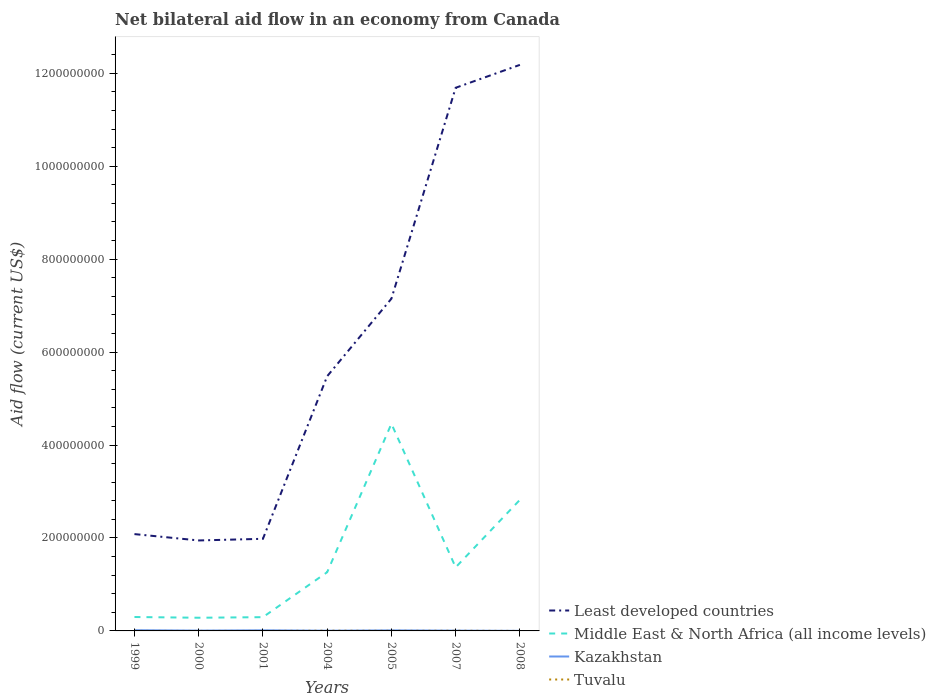How many different coloured lines are there?
Your response must be concise. 4. Across all years, what is the maximum net bilateral aid flow in Middle East & North Africa (all income levels)?
Your response must be concise. 2.84e+07. What is the total net bilateral aid flow in Middle East & North Africa (all income levels) in the graph?
Your answer should be compact. -1.07e+08. What is the difference between the highest and the second highest net bilateral aid flow in Kazakhstan?
Your answer should be compact. 1.35e+06. How many years are there in the graph?
Your response must be concise. 7. Does the graph contain grids?
Provide a succinct answer. No. How many legend labels are there?
Your answer should be compact. 4. How are the legend labels stacked?
Offer a very short reply. Vertical. What is the title of the graph?
Keep it short and to the point. Net bilateral aid flow in an economy from Canada. What is the label or title of the X-axis?
Offer a very short reply. Years. What is the Aid flow (current US$) in Least developed countries in 1999?
Your response must be concise. 2.08e+08. What is the Aid flow (current US$) of Middle East & North Africa (all income levels) in 1999?
Provide a short and direct response. 2.99e+07. What is the Aid flow (current US$) in Kazakhstan in 1999?
Your answer should be very brief. 1.53e+06. What is the Aid flow (current US$) in Least developed countries in 2000?
Your answer should be very brief. 1.95e+08. What is the Aid flow (current US$) of Middle East & North Africa (all income levels) in 2000?
Offer a very short reply. 2.84e+07. What is the Aid flow (current US$) in Kazakhstan in 2000?
Your answer should be compact. 7.10e+05. What is the Aid flow (current US$) in Tuvalu in 2000?
Your answer should be compact. 2.00e+04. What is the Aid flow (current US$) of Least developed countries in 2001?
Keep it short and to the point. 1.98e+08. What is the Aid flow (current US$) of Middle East & North Africa (all income levels) in 2001?
Provide a short and direct response. 2.96e+07. What is the Aid flow (current US$) in Kazakhstan in 2001?
Give a very brief answer. 1.31e+06. What is the Aid flow (current US$) of Least developed countries in 2004?
Your answer should be very brief. 5.48e+08. What is the Aid flow (current US$) in Middle East & North Africa (all income levels) in 2004?
Give a very brief answer. 1.26e+08. What is the Aid flow (current US$) in Kazakhstan in 2004?
Keep it short and to the point. 5.10e+05. What is the Aid flow (current US$) of Tuvalu in 2004?
Offer a terse response. 4.60e+05. What is the Aid flow (current US$) of Least developed countries in 2005?
Your response must be concise. 7.15e+08. What is the Aid flow (current US$) in Middle East & North Africa (all income levels) in 2005?
Keep it short and to the point. 4.46e+08. What is the Aid flow (current US$) in Kazakhstan in 2005?
Offer a very short reply. 1.18e+06. What is the Aid flow (current US$) in Least developed countries in 2007?
Offer a terse response. 1.17e+09. What is the Aid flow (current US$) in Middle East & North Africa (all income levels) in 2007?
Your answer should be very brief. 1.37e+08. What is the Aid flow (current US$) of Kazakhstan in 2007?
Ensure brevity in your answer.  6.30e+05. What is the Aid flow (current US$) in Tuvalu in 2007?
Your answer should be compact. 3.40e+05. What is the Aid flow (current US$) in Least developed countries in 2008?
Keep it short and to the point. 1.22e+09. What is the Aid flow (current US$) of Middle East & North Africa (all income levels) in 2008?
Offer a very short reply. 2.82e+08. What is the Aid flow (current US$) in Kazakhstan in 2008?
Offer a terse response. 1.80e+05. Across all years, what is the maximum Aid flow (current US$) of Least developed countries?
Make the answer very short. 1.22e+09. Across all years, what is the maximum Aid flow (current US$) in Middle East & North Africa (all income levels)?
Offer a terse response. 4.46e+08. Across all years, what is the maximum Aid flow (current US$) in Kazakhstan?
Offer a terse response. 1.53e+06. Across all years, what is the minimum Aid flow (current US$) in Least developed countries?
Offer a terse response. 1.95e+08. Across all years, what is the minimum Aid flow (current US$) of Middle East & North Africa (all income levels)?
Keep it short and to the point. 2.84e+07. Across all years, what is the minimum Aid flow (current US$) of Kazakhstan?
Provide a succinct answer. 1.80e+05. What is the total Aid flow (current US$) of Least developed countries in the graph?
Your answer should be compact. 4.25e+09. What is the total Aid flow (current US$) of Middle East & North Africa (all income levels) in the graph?
Your response must be concise. 1.08e+09. What is the total Aid flow (current US$) of Kazakhstan in the graph?
Your response must be concise. 6.05e+06. What is the total Aid flow (current US$) of Tuvalu in the graph?
Provide a succinct answer. 1.07e+06. What is the difference between the Aid flow (current US$) in Least developed countries in 1999 and that in 2000?
Your answer should be compact. 1.37e+07. What is the difference between the Aid flow (current US$) of Middle East & North Africa (all income levels) in 1999 and that in 2000?
Make the answer very short. 1.58e+06. What is the difference between the Aid flow (current US$) in Kazakhstan in 1999 and that in 2000?
Provide a short and direct response. 8.20e+05. What is the difference between the Aid flow (current US$) of Tuvalu in 1999 and that in 2000?
Keep it short and to the point. 0. What is the difference between the Aid flow (current US$) of Least developed countries in 1999 and that in 2001?
Your response must be concise. 1.02e+07. What is the difference between the Aid flow (current US$) in Tuvalu in 1999 and that in 2001?
Provide a short and direct response. 10000. What is the difference between the Aid flow (current US$) of Least developed countries in 1999 and that in 2004?
Keep it short and to the point. -3.40e+08. What is the difference between the Aid flow (current US$) of Middle East & North Africa (all income levels) in 1999 and that in 2004?
Make the answer very short. -9.64e+07. What is the difference between the Aid flow (current US$) in Kazakhstan in 1999 and that in 2004?
Your response must be concise. 1.02e+06. What is the difference between the Aid flow (current US$) of Tuvalu in 1999 and that in 2004?
Offer a terse response. -4.40e+05. What is the difference between the Aid flow (current US$) of Least developed countries in 1999 and that in 2005?
Provide a short and direct response. -5.07e+08. What is the difference between the Aid flow (current US$) of Middle East & North Africa (all income levels) in 1999 and that in 2005?
Your answer should be very brief. -4.16e+08. What is the difference between the Aid flow (current US$) in Tuvalu in 1999 and that in 2005?
Offer a terse response. -1.80e+05. What is the difference between the Aid flow (current US$) in Least developed countries in 1999 and that in 2007?
Give a very brief answer. -9.60e+08. What is the difference between the Aid flow (current US$) of Middle East & North Africa (all income levels) in 1999 and that in 2007?
Ensure brevity in your answer.  -1.07e+08. What is the difference between the Aid flow (current US$) of Tuvalu in 1999 and that in 2007?
Offer a terse response. -3.20e+05. What is the difference between the Aid flow (current US$) in Least developed countries in 1999 and that in 2008?
Keep it short and to the point. -1.01e+09. What is the difference between the Aid flow (current US$) of Middle East & North Africa (all income levels) in 1999 and that in 2008?
Make the answer very short. -2.52e+08. What is the difference between the Aid flow (current US$) of Kazakhstan in 1999 and that in 2008?
Keep it short and to the point. 1.35e+06. What is the difference between the Aid flow (current US$) in Least developed countries in 2000 and that in 2001?
Ensure brevity in your answer.  -3.52e+06. What is the difference between the Aid flow (current US$) of Middle East & North Africa (all income levels) in 2000 and that in 2001?
Provide a short and direct response. -1.25e+06. What is the difference between the Aid flow (current US$) in Kazakhstan in 2000 and that in 2001?
Your response must be concise. -6.00e+05. What is the difference between the Aid flow (current US$) in Tuvalu in 2000 and that in 2001?
Provide a succinct answer. 10000. What is the difference between the Aid flow (current US$) of Least developed countries in 2000 and that in 2004?
Your answer should be very brief. -3.53e+08. What is the difference between the Aid flow (current US$) of Middle East & North Africa (all income levels) in 2000 and that in 2004?
Provide a short and direct response. -9.80e+07. What is the difference between the Aid flow (current US$) in Kazakhstan in 2000 and that in 2004?
Keep it short and to the point. 2.00e+05. What is the difference between the Aid flow (current US$) in Tuvalu in 2000 and that in 2004?
Your response must be concise. -4.40e+05. What is the difference between the Aid flow (current US$) in Least developed countries in 2000 and that in 2005?
Give a very brief answer. -5.20e+08. What is the difference between the Aid flow (current US$) of Middle East & North Africa (all income levels) in 2000 and that in 2005?
Provide a short and direct response. -4.17e+08. What is the difference between the Aid flow (current US$) in Kazakhstan in 2000 and that in 2005?
Make the answer very short. -4.70e+05. What is the difference between the Aid flow (current US$) in Least developed countries in 2000 and that in 2007?
Ensure brevity in your answer.  -9.74e+08. What is the difference between the Aid flow (current US$) in Middle East & North Africa (all income levels) in 2000 and that in 2007?
Give a very brief answer. -1.08e+08. What is the difference between the Aid flow (current US$) in Kazakhstan in 2000 and that in 2007?
Your answer should be very brief. 8.00e+04. What is the difference between the Aid flow (current US$) of Tuvalu in 2000 and that in 2007?
Your answer should be very brief. -3.20e+05. What is the difference between the Aid flow (current US$) in Least developed countries in 2000 and that in 2008?
Offer a terse response. -1.02e+09. What is the difference between the Aid flow (current US$) in Middle East & North Africa (all income levels) in 2000 and that in 2008?
Provide a short and direct response. -2.54e+08. What is the difference between the Aid flow (current US$) of Kazakhstan in 2000 and that in 2008?
Give a very brief answer. 5.30e+05. What is the difference between the Aid flow (current US$) in Least developed countries in 2001 and that in 2004?
Make the answer very short. -3.50e+08. What is the difference between the Aid flow (current US$) of Middle East & North Africa (all income levels) in 2001 and that in 2004?
Your response must be concise. -9.68e+07. What is the difference between the Aid flow (current US$) in Kazakhstan in 2001 and that in 2004?
Ensure brevity in your answer.  8.00e+05. What is the difference between the Aid flow (current US$) of Tuvalu in 2001 and that in 2004?
Your answer should be very brief. -4.50e+05. What is the difference between the Aid flow (current US$) of Least developed countries in 2001 and that in 2005?
Ensure brevity in your answer.  -5.17e+08. What is the difference between the Aid flow (current US$) of Middle East & North Africa (all income levels) in 2001 and that in 2005?
Give a very brief answer. -4.16e+08. What is the difference between the Aid flow (current US$) in Tuvalu in 2001 and that in 2005?
Provide a succinct answer. -1.90e+05. What is the difference between the Aid flow (current US$) of Least developed countries in 2001 and that in 2007?
Give a very brief answer. -9.71e+08. What is the difference between the Aid flow (current US$) of Middle East & North Africa (all income levels) in 2001 and that in 2007?
Offer a very short reply. -1.07e+08. What is the difference between the Aid flow (current US$) in Kazakhstan in 2001 and that in 2007?
Keep it short and to the point. 6.80e+05. What is the difference between the Aid flow (current US$) of Tuvalu in 2001 and that in 2007?
Your answer should be compact. -3.30e+05. What is the difference between the Aid flow (current US$) in Least developed countries in 2001 and that in 2008?
Your answer should be compact. -1.02e+09. What is the difference between the Aid flow (current US$) in Middle East & North Africa (all income levels) in 2001 and that in 2008?
Keep it short and to the point. -2.52e+08. What is the difference between the Aid flow (current US$) in Kazakhstan in 2001 and that in 2008?
Your response must be concise. 1.13e+06. What is the difference between the Aid flow (current US$) of Tuvalu in 2001 and that in 2008?
Make the answer very short. -10000. What is the difference between the Aid flow (current US$) in Least developed countries in 2004 and that in 2005?
Provide a short and direct response. -1.67e+08. What is the difference between the Aid flow (current US$) in Middle East & North Africa (all income levels) in 2004 and that in 2005?
Offer a terse response. -3.19e+08. What is the difference between the Aid flow (current US$) in Kazakhstan in 2004 and that in 2005?
Your answer should be compact. -6.70e+05. What is the difference between the Aid flow (current US$) in Least developed countries in 2004 and that in 2007?
Keep it short and to the point. -6.21e+08. What is the difference between the Aid flow (current US$) in Middle East & North Africa (all income levels) in 2004 and that in 2007?
Your answer should be compact. -1.05e+07. What is the difference between the Aid flow (current US$) of Kazakhstan in 2004 and that in 2007?
Ensure brevity in your answer.  -1.20e+05. What is the difference between the Aid flow (current US$) in Tuvalu in 2004 and that in 2007?
Your answer should be compact. 1.20e+05. What is the difference between the Aid flow (current US$) of Least developed countries in 2004 and that in 2008?
Your response must be concise. -6.70e+08. What is the difference between the Aid flow (current US$) in Middle East & North Africa (all income levels) in 2004 and that in 2008?
Your response must be concise. -1.56e+08. What is the difference between the Aid flow (current US$) of Kazakhstan in 2004 and that in 2008?
Make the answer very short. 3.30e+05. What is the difference between the Aid flow (current US$) of Least developed countries in 2005 and that in 2007?
Your response must be concise. -4.54e+08. What is the difference between the Aid flow (current US$) of Middle East & North Africa (all income levels) in 2005 and that in 2007?
Ensure brevity in your answer.  3.09e+08. What is the difference between the Aid flow (current US$) of Kazakhstan in 2005 and that in 2007?
Your answer should be very brief. 5.50e+05. What is the difference between the Aid flow (current US$) in Least developed countries in 2005 and that in 2008?
Provide a short and direct response. -5.03e+08. What is the difference between the Aid flow (current US$) in Middle East & North Africa (all income levels) in 2005 and that in 2008?
Keep it short and to the point. 1.64e+08. What is the difference between the Aid flow (current US$) of Kazakhstan in 2005 and that in 2008?
Offer a very short reply. 1.00e+06. What is the difference between the Aid flow (current US$) in Least developed countries in 2007 and that in 2008?
Your answer should be compact. -4.93e+07. What is the difference between the Aid flow (current US$) in Middle East & North Africa (all income levels) in 2007 and that in 2008?
Offer a terse response. -1.45e+08. What is the difference between the Aid flow (current US$) of Least developed countries in 1999 and the Aid flow (current US$) of Middle East & North Africa (all income levels) in 2000?
Offer a very short reply. 1.80e+08. What is the difference between the Aid flow (current US$) in Least developed countries in 1999 and the Aid flow (current US$) in Kazakhstan in 2000?
Give a very brief answer. 2.08e+08. What is the difference between the Aid flow (current US$) in Least developed countries in 1999 and the Aid flow (current US$) in Tuvalu in 2000?
Make the answer very short. 2.08e+08. What is the difference between the Aid flow (current US$) of Middle East & North Africa (all income levels) in 1999 and the Aid flow (current US$) of Kazakhstan in 2000?
Give a very brief answer. 2.92e+07. What is the difference between the Aid flow (current US$) in Middle East & North Africa (all income levels) in 1999 and the Aid flow (current US$) in Tuvalu in 2000?
Keep it short and to the point. 2.99e+07. What is the difference between the Aid flow (current US$) in Kazakhstan in 1999 and the Aid flow (current US$) in Tuvalu in 2000?
Your answer should be very brief. 1.51e+06. What is the difference between the Aid flow (current US$) of Least developed countries in 1999 and the Aid flow (current US$) of Middle East & North Africa (all income levels) in 2001?
Ensure brevity in your answer.  1.79e+08. What is the difference between the Aid flow (current US$) of Least developed countries in 1999 and the Aid flow (current US$) of Kazakhstan in 2001?
Offer a very short reply. 2.07e+08. What is the difference between the Aid flow (current US$) of Least developed countries in 1999 and the Aid flow (current US$) of Tuvalu in 2001?
Make the answer very short. 2.08e+08. What is the difference between the Aid flow (current US$) in Middle East & North Africa (all income levels) in 1999 and the Aid flow (current US$) in Kazakhstan in 2001?
Offer a terse response. 2.86e+07. What is the difference between the Aid flow (current US$) of Middle East & North Africa (all income levels) in 1999 and the Aid flow (current US$) of Tuvalu in 2001?
Your response must be concise. 2.99e+07. What is the difference between the Aid flow (current US$) of Kazakhstan in 1999 and the Aid flow (current US$) of Tuvalu in 2001?
Give a very brief answer. 1.52e+06. What is the difference between the Aid flow (current US$) of Least developed countries in 1999 and the Aid flow (current US$) of Middle East & North Africa (all income levels) in 2004?
Provide a short and direct response. 8.20e+07. What is the difference between the Aid flow (current US$) in Least developed countries in 1999 and the Aid flow (current US$) in Kazakhstan in 2004?
Your answer should be very brief. 2.08e+08. What is the difference between the Aid flow (current US$) in Least developed countries in 1999 and the Aid flow (current US$) in Tuvalu in 2004?
Your answer should be compact. 2.08e+08. What is the difference between the Aid flow (current US$) of Middle East & North Africa (all income levels) in 1999 and the Aid flow (current US$) of Kazakhstan in 2004?
Ensure brevity in your answer.  2.94e+07. What is the difference between the Aid flow (current US$) of Middle East & North Africa (all income levels) in 1999 and the Aid flow (current US$) of Tuvalu in 2004?
Offer a terse response. 2.95e+07. What is the difference between the Aid flow (current US$) of Kazakhstan in 1999 and the Aid flow (current US$) of Tuvalu in 2004?
Provide a short and direct response. 1.07e+06. What is the difference between the Aid flow (current US$) of Least developed countries in 1999 and the Aid flow (current US$) of Middle East & North Africa (all income levels) in 2005?
Make the answer very short. -2.37e+08. What is the difference between the Aid flow (current US$) in Least developed countries in 1999 and the Aid flow (current US$) in Kazakhstan in 2005?
Provide a short and direct response. 2.07e+08. What is the difference between the Aid flow (current US$) in Least developed countries in 1999 and the Aid flow (current US$) in Tuvalu in 2005?
Your response must be concise. 2.08e+08. What is the difference between the Aid flow (current US$) of Middle East & North Africa (all income levels) in 1999 and the Aid flow (current US$) of Kazakhstan in 2005?
Your answer should be compact. 2.88e+07. What is the difference between the Aid flow (current US$) in Middle East & North Africa (all income levels) in 1999 and the Aid flow (current US$) in Tuvalu in 2005?
Provide a short and direct response. 2.97e+07. What is the difference between the Aid flow (current US$) in Kazakhstan in 1999 and the Aid flow (current US$) in Tuvalu in 2005?
Provide a succinct answer. 1.33e+06. What is the difference between the Aid flow (current US$) in Least developed countries in 1999 and the Aid flow (current US$) in Middle East & North Africa (all income levels) in 2007?
Ensure brevity in your answer.  7.15e+07. What is the difference between the Aid flow (current US$) of Least developed countries in 1999 and the Aid flow (current US$) of Kazakhstan in 2007?
Ensure brevity in your answer.  2.08e+08. What is the difference between the Aid flow (current US$) in Least developed countries in 1999 and the Aid flow (current US$) in Tuvalu in 2007?
Give a very brief answer. 2.08e+08. What is the difference between the Aid flow (current US$) of Middle East & North Africa (all income levels) in 1999 and the Aid flow (current US$) of Kazakhstan in 2007?
Your response must be concise. 2.93e+07. What is the difference between the Aid flow (current US$) in Middle East & North Africa (all income levels) in 1999 and the Aid flow (current US$) in Tuvalu in 2007?
Provide a short and direct response. 2.96e+07. What is the difference between the Aid flow (current US$) in Kazakhstan in 1999 and the Aid flow (current US$) in Tuvalu in 2007?
Make the answer very short. 1.19e+06. What is the difference between the Aid flow (current US$) in Least developed countries in 1999 and the Aid flow (current US$) in Middle East & North Africa (all income levels) in 2008?
Give a very brief answer. -7.37e+07. What is the difference between the Aid flow (current US$) of Least developed countries in 1999 and the Aid flow (current US$) of Kazakhstan in 2008?
Provide a succinct answer. 2.08e+08. What is the difference between the Aid flow (current US$) of Least developed countries in 1999 and the Aid flow (current US$) of Tuvalu in 2008?
Make the answer very short. 2.08e+08. What is the difference between the Aid flow (current US$) of Middle East & North Africa (all income levels) in 1999 and the Aid flow (current US$) of Kazakhstan in 2008?
Make the answer very short. 2.98e+07. What is the difference between the Aid flow (current US$) in Middle East & North Africa (all income levels) in 1999 and the Aid flow (current US$) in Tuvalu in 2008?
Provide a succinct answer. 2.99e+07. What is the difference between the Aid flow (current US$) of Kazakhstan in 1999 and the Aid flow (current US$) of Tuvalu in 2008?
Give a very brief answer. 1.51e+06. What is the difference between the Aid flow (current US$) of Least developed countries in 2000 and the Aid flow (current US$) of Middle East & North Africa (all income levels) in 2001?
Provide a succinct answer. 1.65e+08. What is the difference between the Aid flow (current US$) of Least developed countries in 2000 and the Aid flow (current US$) of Kazakhstan in 2001?
Offer a terse response. 1.93e+08. What is the difference between the Aid flow (current US$) of Least developed countries in 2000 and the Aid flow (current US$) of Tuvalu in 2001?
Give a very brief answer. 1.95e+08. What is the difference between the Aid flow (current US$) in Middle East & North Africa (all income levels) in 2000 and the Aid flow (current US$) in Kazakhstan in 2001?
Your answer should be very brief. 2.70e+07. What is the difference between the Aid flow (current US$) in Middle East & North Africa (all income levels) in 2000 and the Aid flow (current US$) in Tuvalu in 2001?
Provide a short and direct response. 2.84e+07. What is the difference between the Aid flow (current US$) in Least developed countries in 2000 and the Aid flow (current US$) in Middle East & North Africa (all income levels) in 2004?
Keep it short and to the point. 6.83e+07. What is the difference between the Aid flow (current US$) of Least developed countries in 2000 and the Aid flow (current US$) of Kazakhstan in 2004?
Your answer should be compact. 1.94e+08. What is the difference between the Aid flow (current US$) of Least developed countries in 2000 and the Aid flow (current US$) of Tuvalu in 2004?
Your answer should be compact. 1.94e+08. What is the difference between the Aid flow (current US$) in Middle East & North Africa (all income levels) in 2000 and the Aid flow (current US$) in Kazakhstan in 2004?
Offer a very short reply. 2.78e+07. What is the difference between the Aid flow (current US$) in Middle East & North Africa (all income levels) in 2000 and the Aid flow (current US$) in Tuvalu in 2004?
Offer a terse response. 2.79e+07. What is the difference between the Aid flow (current US$) of Kazakhstan in 2000 and the Aid flow (current US$) of Tuvalu in 2004?
Ensure brevity in your answer.  2.50e+05. What is the difference between the Aid flow (current US$) in Least developed countries in 2000 and the Aid flow (current US$) in Middle East & North Africa (all income levels) in 2005?
Ensure brevity in your answer.  -2.51e+08. What is the difference between the Aid flow (current US$) in Least developed countries in 2000 and the Aid flow (current US$) in Kazakhstan in 2005?
Keep it short and to the point. 1.94e+08. What is the difference between the Aid flow (current US$) of Least developed countries in 2000 and the Aid flow (current US$) of Tuvalu in 2005?
Provide a short and direct response. 1.94e+08. What is the difference between the Aid flow (current US$) of Middle East & North Africa (all income levels) in 2000 and the Aid flow (current US$) of Kazakhstan in 2005?
Your answer should be very brief. 2.72e+07. What is the difference between the Aid flow (current US$) in Middle East & North Africa (all income levels) in 2000 and the Aid flow (current US$) in Tuvalu in 2005?
Give a very brief answer. 2.82e+07. What is the difference between the Aid flow (current US$) of Kazakhstan in 2000 and the Aid flow (current US$) of Tuvalu in 2005?
Give a very brief answer. 5.10e+05. What is the difference between the Aid flow (current US$) in Least developed countries in 2000 and the Aid flow (current US$) in Middle East & North Africa (all income levels) in 2007?
Make the answer very short. 5.78e+07. What is the difference between the Aid flow (current US$) in Least developed countries in 2000 and the Aid flow (current US$) in Kazakhstan in 2007?
Your answer should be very brief. 1.94e+08. What is the difference between the Aid flow (current US$) of Least developed countries in 2000 and the Aid flow (current US$) of Tuvalu in 2007?
Your answer should be compact. 1.94e+08. What is the difference between the Aid flow (current US$) of Middle East & North Africa (all income levels) in 2000 and the Aid flow (current US$) of Kazakhstan in 2007?
Offer a very short reply. 2.77e+07. What is the difference between the Aid flow (current US$) of Middle East & North Africa (all income levels) in 2000 and the Aid flow (current US$) of Tuvalu in 2007?
Offer a terse response. 2.80e+07. What is the difference between the Aid flow (current US$) in Least developed countries in 2000 and the Aid flow (current US$) in Middle East & North Africa (all income levels) in 2008?
Your answer should be compact. -8.74e+07. What is the difference between the Aid flow (current US$) of Least developed countries in 2000 and the Aid flow (current US$) of Kazakhstan in 2008?
Keep it short and to the point. 1.94e+08. What is the difference between the Aid flow (current US$) of Least developed countries in 2000 and the Aid flow (current US$) of Tuvalu in 2008?
Offer a very short reply. 1.95e+08. What is the difference between the Aid flow (current US$) of Middle East & North Africa (all income levels) in 2000 and the Aid flow (current US$) of Kazakhstan in 2008?
Provide a succinct answer. 2.82e+07. What is the difference between the Aid flow (current US$) of Middle East & North Africa (all income levels) in 2000 and the Aid flow (current US$) of Tuvalu in 2008?
Your response must be concise. 2.83e+07. What is the difference between the Aid flow (current US$) in Kazakhstan in 2000 and the Aid flow (current US$) in Tuvalu in 2008?
Give a very brief answer. 6.90e+05. What is the difference between the Aid flow (current US$) in Least developed countries in 2001 and the Aid flow (current US$) in Middle East & North Africa (all income levels) in 2004?
Provide a short and direct response. 7.18e+07. What is the difference between the Aid flow (current US$) of Least developed countries in 2001 and the Aid flow (current US$) of Kazakhstan in 2004?
Ensure brevity in your answer.  1.98e+08. What is the difference between the Aid flow (current US$) of Least developed countries in 2001 and the Aid flow (current US$) of Tuvalu in 2004?
Provide a short and direct response. 1.98e+08. What is the difference between the Aid flow (current US$) in Middle East & North Africa (all income levels) in 2001 and the Aid flow (current US$) in Kazakhstan in 2004?
Your response must be concise. 2.91e+07. What is the difference between the Aid flow (current US$) in Middle East & North Africa (all income levels) in 2001 and the Aid flow (current US$) in Tuvalu in 2004?
Give a very brief answer. 2.92e+07. What is the difference between the Aid flow (current US$) in Kazakhstan in 2001 and the Aid flow (current US$) in Tuvalu in 2004?
Keep it short and to the point. 8.50e+05. What is the difference between the Aid flow (current US$) of Least developed countries in 2001 and the Aid flow (current US$) of Middle East & North Africa (all income levels) in 2005?
Make the answer very short. -2.48e+08. What is the difference between the Aid flow (current US$) of Least developed countries in 2001 and the Aid flow (current US$) of Kazakhstan in 2005?
Make the answer very short. 1.97e+08. What is the difference between the Aid flow (current US$) of Least developed countries in 2001 and the Aid flow (current US$) of Tuvalu in 2005?
Your answer should be compact. 1.98e+08. What is the difference between the Aid flow (current US$) of Middle East & North Africa (all income levels) in 2001 and the Aid flow (current US$) of Kazakhstan in 2005?
Provide a succinct answer. 2.84e+07. What is the difference between the Aid flow (current US$) of Middle East & North Africa (all income levels) in 2001 and the Aid flow (current US$) of Tuvalu in 2005?
Give a very brief answer. 2.94e+07. What is the difference between the Aid flow (current US$) of Kazakhstan in 2001 and the Aid flow (current US$) of Tuvalu in 2005?
Provide a succinct answer. 1.11e+06. What is the difference between the Aid flow (current US$) of Least developed countries in 2001 and the Aid flow (current US$) of Middle East & North Africa (all income levels) in 2007?
Ensure brevity in your answer.  6.14e+07. What is the difference between the Aid flow (current US$) of Least developed countries in 2001 and the Aid flow (current US$) of Kazakhstan in 2007?
Your response must be concise. 1.98e+08. What is the difference between the Aid flow (current US$) in Least developed countries in 2001 and the Aid flow (current US$) in Tuvalu in 2007?
Offer a terse response. 1.98e+08. What is the difference between the Aid flow (current US$) of Middle East & North Africa (all income levels) in 2001 and the Aid flow (current US$) of Kazakhstan in 2007?
Your answer should be very brief. 2.90e+07. What is the difference between the Aid flow (current US$) in Middle East & North Africa (all income levels) in 2001 and the Aid flow (current US$) in Tuvalu in 2007?
Your answer should be very brief. 2.93e+07. What is the difference between the Aid flow (current US$) of Kazakhstan in 2001 and the Aid flow (current US$) of Tuvalu in 2007?
Your answer should be compact. 9.70e+05. What is the difference between the Aid flow (current US$) in Least developed countries in 2001 and the Aid flow (current US$) in Middle East & North Africa (all income levels) in 2008?
Provide a short and direct response. -8.39e+07. What is the difference between the Aid flow (current US$) in Least developed countries in 2001 and the Aid flow (current US$) in Kazakhstan in 2008?
Provide a succinct answer. 1.98e+08. What is the difference between the Aid flow (current US$) of Least developed countries in 2001 and the Aid flow (current US$) of Tuvalu in 2008?
Give a very brief answer. 1.98e+08. What is the difference between the Aid flow (current US$) in Middle East & North Africa (all income levels) in 2001 and the Aid flow (current US$) in Kazakhstan in 2008?
Your response must be concise. 2.94e+07. What is the difference between the Aid flow (current US$) of Middle East & North Africa (all income levels) in 2001 and the Aid flow (current US$) of Tuvalu in 2008?
Give a very brief answer. 2.96e+07. What is the difference between the Aid flow (current US$) in Kazakhstan in 2001 and the Aid flow (current US$) in Tuvalu in 2008?
Make the answer very short. 1.29e+06. What is the difference between the Aid flow (current US$) in Least developed countries in 2004 and the Aid flow (current US$) in Middle East & North Africa (all income levels) in 2005?
Ensure brevity in your answer.  1.02e+08. What is the difference between the Aid flow (current US$) in Least developed countries in 2004 and the Aid flow (current US$) in Kazakhstan in 2005?
Make the answer very short. 5.47e+08. What is the difference between the Aid flow (current US$) in Least developed countries in 2004 and the Aid flow (current US$) in Tuvalu in 2005?
Give a very brief answer. 5.48e+08. What is the difference between the Aid flow (current US$) of Middle East & North Africa (all income levels) in 2004 and the Aid flow (current US$) of Kazakhstan in 2005?
Your answer should be very brief. 1.25e+08. What is the difference between the Aid flow (current US$) in Middle East & North Africa (all income levels) in 2004 and the Aid flow (current US$) in Tuvalu in 2005?
Give a very brief answer. 1.26e+08. What is the difference between the Aid flow (current US$) in Kazakhstan in 2004 and the Aid flow (current US$) in Tuvalu in 2005?
Offer a terse response. 3.10e+05. What is the difference between the Aid flow (current US$) in Least developed countries in 2004 and the Aid flow (current US$) in Middle East & North Africa (all income levels) in 2007?
Your answer should be very brief. 4.11e+08. What is the difference between the Aid flow (current US$) of Least developed countries in 2004 and the Aid flow (current US$) of Kazakhstan in 2007?
Ensure brevity in your answer.  5.47e+08. What is the difference between the Aid flow (current US$) in Least developed countries in 2004 and the Aid flow (current US$) in Tuvalu in 2007?
Ensure brevity in your answer.  5.48e+08. What is the difference between the Aid flow (current US$) in Middle East & North Africa (all income levels) in 2004 and the Aid flow (current US$) in Kazakhstan in 2007?
Your response must be concise. 1.26e+08. What is the difference between the Aid flow (current US$) in Middle East & North Africa (all income levels) in 2004 and the Aid flow (current US$) in Tuvalu in 2007?
Your answer should be very brief. 1.26e+08. What is the difference between the Aid flow (current US$) in Kazakhstan in 2004 and the Aid flow (current US$) in Tuvalu in 2007?
Keep it short and to the point. 1.70e+05. What is the difference between the Aid flow (current US$) in Least developed countries in 2004 and the Aid flow (current US$) in Middle East & North Africa (all income levels) in 2008?
Ensure brevity in your answer.  2.66e+08. What is the difference between the Aid flow (current US$) of Least developed countries in 2004 and the Aid flow (current US$) of Kazakhstan in 2008?
Give a very brief answer. 5.48e+08. What is the difference between the Aid flow (current US$) in Least developed countries in 2004 and the Aid flow (current US$) in Tuvalu in 2008?
Your answer should be very brief. 5.48e+08. What is the difference between the Aid flow (current US$) in Middle East & North Africa (all income levels) in 2004 and the Aid flow (current US$) in Kazakhstan in 2008?
Offer a terse response. 1.26e+08. What is the difference between the Aid flow (current US$) of Middle East & North Africa (all income levels) in 2004 and the Aid flow (current US$) of Tuvalu in 2008?
Offer a terse response. 1.26e+08. What is the difference between the Aid flow (current US$) in Least developed countries in 2005 and the Aid flow (current US$) in Middle East & North Africa (all income levels) in 2007?
Provide a succinct answer. 5.78e+08. What is the difference between the Aid flow (current US$) of Least developed countries in 2005 and the Aid flow (current US$) of Kazakhstan in 2007?
Make the answer very short. 7.14e+08. What is the difference between the Aid flow (current US$) of Least developed countries in 2005 and the Aid flow (current US$) of Tuvalu in 2007?
Your answer should be very brief. 7.15e+08. What is the difference between the Aid flow (current US$) of Middle East & North Africa (all income levels) in 2005 and the Aid flow (current US$) of Kazakhstan in 2007?
Ensure brevity in your answer.  4.45e+08. What is the difference between the Aid flow (current US$) in Middle East & North Africa (all income levels) in 2005 and the Aid flow (current US$) in Tuvalu in 2007?
Provide a short and direct response. 4.45e+08. What is the difference between the Aid flow (current US$) of Kazakhstan in 2005 and the Aid flow (current US$) of Tuvalu in 2007?
Your answer should be very brief. 8.40e+05. What is the difference between the Aid flow (current US$) in Least developed countries in 2005 and the Aid flow (current US$) in Middle East & North Africa (all income levels) in 2008?
Offer a terse response. 4.33e+08. What is the difference between the Aid flow (current US$) in Least developed countries in 2005 and the Aid flow (current US$) in Kazakhstan in 2008?
Ensure brevity in your answer.  7.15e+08. What is the difference between the Aid flow (current US$) of Least developed countries in 2005 and the Aid flow (current US$) of Tuvalu in 2008?
Your answer should be very brief. 7.15e+08. What is the difference between the Aid flow (current US$) in Middle East & North Africa (all income levels) in 2005 and the Aid flow (current US$) in Kazakhstan in 2008?
Provide a succinct answer. 4.46e+08. What is the difference between the Aid flow (current US$) in Middle East & North Africa (all income levels) in 2005 and the Aid flow (current US$) in Tuvalu in 2008?
Make the answer very short. 4.46e+08. What is the difference between the Aid flow (current US$) of Kazakhstan in 2005 and the Aid flow (current US$) of Tuvalu in 2008?
Offer a terse response. 1.16e+06. What is the difference between the Aid flow (current US$) of Least developed countries in 2007 and the Aid flow (current US$) of Middle East & North Africa (all income levels) in 2008?
Your answer should be compact. 8.87e+08. What is the difference between the Aid flow (current US$) of Least developed countries in 2007 and the Aid flow (current US$) of Kazakhstan in 2008?
Ensure brevity in your answer.  1.17e+09. What is the difference between the Aid flow (current US$) of Least developed countries in 2007 and the Aid flow (current US$) of Tuvalu in 2008?
Give a very brief answer. 1.17e+09. What is the difference between the Aid flow (current US$) in Middle East & North Africa (all income levels) in 2007 and the Aid flow (current US$) in Kazakhstan in 2008?
Offer a terse response. 1.37e+08. What is the difference between the Aid flow (current US$) in Middle East & North Africa (all income levels) in 2007 and the Aid flow (current US$) in Tuvalu in 2008?
Your answer should be compact. 1.37e+08. What is the difference between the Aid flow (current US$) of Kazakhstan in 2007 and the Aid flow (current US$) of Tuvalu in 2008?
Provide a succinct answer. 6.10e+05. What is the average Aid flow (current US$) of Least developed countries per year?
Your answer should be very brief. 6.07e+08. What is the average Aid flow (current US$) of Middle East & North Africa (all income levels) per year?
Your response must be concise. 1.54e+08. What is the average Aid flow (current US$) in Kazakhstan per year?
Your answer should be very brief. 8.64e+05. What is the average Aid flow (current US$) of Tuvalu per year?
Ensure brevity in your answer.  1.53e+05. In the year 1999, what is the difference between the Aid flow (current US$) of Least developed countries and Aid flow (current US$) of Middle East & North Africa (all income levels)?
Your answer should be compact. 1.78e+08. In the year 1999, what is the difference between the Aid flow (current US$) in Least developed countries and Aid flow (current US$) in Kazakhstan?
Keep it short and to the point. 2.07e+08. In the year 1999, what is the difference between the Aid flow (current US$) in Least developed countries and Aid flow (current US$) in Tuvalu?
Give a very brief answer. 2.08e+08. In the year 1999, what is the difference between the Aid flow (current US$) of Middle East & North Africa (all income levels) and Aid flow (current US$) of Kazakhstan?
Your answer should be compact. 2.84e+07. In the year 1999, what is the difference between the Aid flow (current US$) in Middle East & North Africa (all income levels) and Aid flow (current US$) in Tuvalu?
Offer a very short reply. 2.99e+07. In the year 1999, what is the difference between the Aid flow (current US$) of Kazakhstan and Aid flow (current US$) of Tuvalu?
Keep it short and to the point. 1.51e+06. In the year 2000, what is the difference between the Aid flow (current US$) in Least developed countries and Aid flow (current US$) in Middle East & North Africa (all income levels)?
Offer a terse response. 1.66e+08. In the year 2000, what is the difference between the Aid flow (current US$) in Least developed countries and Aid flow (current US$) in Kazakhstan?
Keep it short and to the point. 1.94e+08. In the year 2000, what is the difference between the Aid flow (current US$) in Least developed countries and Aid flow (current US$) in Tuvalu?
Offer a terse response. 1.95e+08. In the year 2000, what is the difference between the Aid flow (current US$) of Middle East & North Africa (all income levels) and Aid flow (current US$) of Kazakhstan?
Your response must be concise. 2.76e+07. In the year 2000, what is the difference between the Aid flow (current US$) of Middle East & North Africa (all income levels) and Aid flow (current US$) of Tuvalu?
Offer a very short reply. 2.83e+07. In the year 2000, what is the difference between the Aid flow (current US$) of Kazakhstan and Aid flow (current US$) of Tuvalu?
Your response must be concise. 6.90e+05. In the year 2001, what is the difference between the Aid flow (current US$) in Least developed countries and Aid flow (current US$) in Middle East & North Africa (all income levels)?
Give a very brief answer. 1.69e+08. In the year 2001, what is the difference between the Aid flow (current US$) in Least developed countries and Aid flow (current US$) in Kazakhstan?
Give a very brief answer. 1.97e+08. In the year 2001, what is the difference between the Aid flow (current US$) in Least developed countries and Aid flow (current US$) in Tuvalu?
Ensure brevity in your answer.  1.98e+08. In the year 2001, what is the difference between the Aid flow (current US$) in Middle East & North Africa (all income levels) and Aid flow (current US$) in Kazakhstan?
Provide a short and direct response. 2.83e+07. In the year 2001, what is the difference between the Aid flow (current US$) in Middle East & North Africa (all income levels) and Aid flow (current US$) in Tuvalu?
Your answer should be very brief. 2.96e+07. In the year 2001, what is the difference between the Aid flow (current US$) of Kazakhstan and Aid flow (current US$) of Tuvalu?
Your answer should be compact. 1.30e+06. In the year 2004, what is the difference between the Aid flow (current US$) in Least developed countries and Aid flow (current US$) in Middle East & North Africa (all income levels)?
Ensure brevity in your answer.  4.22e+08. In the year 2004, what is the difference between the Aid flow (current US$) of Least developed countries and Aid flow (current US$) of Kazakhstan?
Give a very brief answer. 5.48e+08. In the year 2004, what is the difference between the Aid flow (current US$) of Least developed countries and Aid flow (current US$) of Tuvalu?
Make the answer very short. 5.48e+08. In the year 2004, what is the difference between the Aid flow (current US$) in Middle East & North Africa (all income levels) and Aid flow (current US$) in Kazakhstan?
Make the answer very short. 1.26e+08. In the year 2004, what is the difference between the Aid flow (current US$) of Middle East & North Africa (all income levels) and Aid flow (current US$) of Tuvalu?
Provide a short and direct response. 1.26e+08. In the year 2004, what is the difference between the Aid flow (current US$) of Kazakhstan and Aid flow (current US$) of Tuvalu?
Offer a very short reply. 5.00e+04. In the year 2005, what is the difference between the Aid flow (current US$) of Least developed countries and Aid flow (current US$) of Middle East & North Africa (all income levels)?
Provide a succinct answer. 2.69e+08. In the year 2005, what is the difference between the Aid flow (current US$) in Least developed countries and Aid flow (current US$) in Kazakhstan?
Provide a short and direct response. 7.14e+08. In the year 2005, what is the difference between the Aid flow (current US$) in Least developed countries and Aid flow (current US$) in Tuvalu?
Provide a succinct answer. 7.15e+08. In the year 2005, what is the difference between the Aid flow (current US$) in Middle East & North Africa (all income levels) and Aid flow (current US$) in Kazakhstan?
Offer a terse response. 4.45e+08. In the year 2005, what is the difference between the Aid flow (current US$) in Middle East & North Africa (all income levels) and Aid flow (current US$) in Tuvalu?
Provide a succinct answer. 4.46e+08. In the year 2005, what is the difference between the Aid flow (current US$) of Kazakhstan and Aid flow (current US$) of Tuvalu?
Your response must be concise. 9.80e+05. In the year 2007, what is the difference between the Aid flow (current US$) in Least developed countries and Aid flow (current US$) in Middle East & North Africa (all income levels)?
Keep it short and to the point. 1.03e+09. In the year 2007, what is the difference between the Aid flow (current US$) in Least developed countries and Aid flow (current US$) in Kazakhstan?
Offer a terse response. 1.17e+09. In the year 2007, what is the difference between the Aid flow (current US$) of Least developed countries and Aid flow (current US$) of Tuvalu?
Your response must be concise. 1.17e+09. In the year 2007, what is the difference between the Aid flow (current US$) of Middle East & North Africa (all income levels) and Aid flow (current US$) of Kazakhstan?
Offer a terse response. 1.36e+08. In the year 2007, what is the difference between the Aid flow (current US$) in Middle East & North Africa (all income levels) and Aid flow (current US$) in Tuvalu?
Offer a terse response. 1.36e+08. In the year 2008, what is the difference between the Aid flow (current US$) in Least developed countries and Aid flow (current US$) in Middle East & North Africa (all income levels)?
Offer a terse response. 9.36e+08. In the year 2008, what is the difference between the Aid flow (current US$) in Least developed countries and Aid flow (current US$) in Kazakhstan?
Ensure brevity in your answer.  1.22e+09. In the year 2008, what is the difference between the Aid flow (current US$) in Least developed countries and Aid flow (current US$) in Tuvalu?
Ensure brevity in your answer.  1.22e+09. In the year 2008, what is the difference between the Aid flow (current US$) in Middle East & North Africa (all income levels) and Aid flow (current US$) in Kazakhstan?
Offer a terse response. 2.82e+08. In the year 2008, what is the difference between the Aid flow (current US$) in Middle East & North Africa (all income levels) and Aid flow (current US$) in Tuvalu?
Make the answer very short. 2.82e+08. In the year 2008, what is the difference between the Aid flow (current US$) in Kazakhstan and Aid flow (current US$) in Tuvalu?
Give a very brief answer. 1.60e+05. What is the ratio of the Aid flow (current US$) in Least developed countries in 1999 to that in 2000?
Your response must be concise. 1.07. What is the ratio of the Aid flow (current US$) of Middle East & North Africa (all income levels) in 1999 to that in 2000?
Provide a succinct answer. 1.06. What is the ratio of the Aid flow (current US$) in Kazakhstan in 1999 to that in 2000?
Offer a terse response. 2.15. What is the ratio of the Aid flow (current US$) in Tuvalu in 1999 to that in 2000?
Offer a terse response. 1. What is the ratio of the Aid flow (current US$) in Least developed countries in 1999 to that in 2001?
Your answer should be compact. 1.05. What is the ratio of the Aid flow (current US$) in Middle East & North Africa (all income levels) in 1999 to that in 2001?
Offer a terse response. 1.01. What is the ratio of the Aid flow (current US$) of Kazakhstan in 1999 to that in 2001?
Your answer should be compact. 1.17. What is the ratio of the Aid flow (current US$) in Tuvalu in 1999 to that in 2001?
Your answer should be very brief. 2. What is the ratio of the Aid flow (current US$) of Least developed countries in 1999 to that in 2004?
Offer a very short reply. 0.38. What is the ratio of the Aid flow (current US$) in Middle East & North Africa (all income levels) in 1999 to that in 2004?
Keep it short and to the point. 0.24. What is the ratio of the Aid flow (current US$) of Kazakhstan in 1999 to that in 2004?
Your answer should be very brief. 3. What is the ratio of the Aid flow (current US$) in Tuvalu in 1999 to that in 2004?
Offer a very short reply. 0.04. What is the ratio of the Aid flow (current US$) of Least developed countries in 1999 to that in 2005?
Make the answer very short. 0.29. What is the ratio of the Aid flow (current US$) of Middle East & North Africa (all income levels) in 1999 to that in 2005?
Your answer should be compact. 0.07. What is the ratio of the Aid flow (current US$) in Kazakhstan in 1999 to that in 2005?
Your response must be concise. 1.3. What is the ratio of the Aid flow (current US$) of Least developed countries in 1999 to that in 2007?
Your response must be concise. 0.18. What is the ratio of the Aid flow (current US$) of Middle East & North Africa (all income levels) in 1999 to that in 2007?
Ensure brevity in your answer.  0.22. What is the ratio of the Aid flow (current US$) in Kazakhstan in 1999 to that in 2007?
Your answer should be very brief. 2.43. What is the ratio of the Aid flow (current US$) in Tuvalu in 1999 to that in 2007?
Ensure brevity in your answer.  0.06. What is the ratio of the Aid flow (current US$) in Least developed countries in 1999 to that in 2008?
Your answer should be very brief. 0.17. What is the ratio of the Aid flow (current US$) of Middle East & North Africa (all income levels) in 1999 to that in 2008?
Provide a short and direct response. 0.11. What is the ratio of the Aid flow (current US$) of Tuvalu in 1999 to that in 2008?
Your answer should be very brief. 1. What is the ratio of the Aid flow (current US$) of Least developed countries in 2000 to that in 2001?
Keep it short and to the point. 0.98. What is the ratio of the Aid flow (current US$) of Middle East & North Africa (all income levels) in 2000 to that in 2001?
Provide a succinct answer. 0.96. What is the ratio of the Aid flow (current US$) in Kazakhstan in 2000 to that in 2001?
Provide a succinct answer. 0.54. What is the ratio of the Aid flow (current US$) of Least developed countries in 2000 to that in 2004?
Give a very brief answer. 0.36. What is the ratio of the Aid flow (current US$) in Middle East & North Africa (all income levels) in 2000 to that in 2004?
Your answer should be compact. 0.22. What is the ratio of the Aid flow (current US$) in Kazakhstan in 2000 to that in 2004?
Your response must be concise. 1.39. What is the ratio of the Aid flow (current US$) in Tuvalu in 2000 to that in 2004?
Your answer should be compact. 0.04. What is the ratio of the Aid flow (current US$) in Least developed countries in 2000 to that in 2005?
Keep it short and to the point. 0.27. What is the ratio of the Aid flow (current US$) of Middle East & North Africa (all income levels) in 2000 to that in 2005?
Your answer should be compact. 0.06. What is the ratio of the Aid flow (current US$) of Kazakhstan in 2000 to that in 2005?
Keep it short and to the point. 0.6. What is the ratio of the Aid flow (current US$) of Tuvalu in 2000 to that in 2005?
Ensure brevity in your answer.  0.1. What is the ratio of the Aid flow (current US$) in Least developed countries in 2000 to that in 2007?
Provide a succinct answer. 0.17. What is the ratio of the Aid flow (current US$) of Middle East & North Africa (all income levels) in 2000 to that in 2007?
Keep it short and to the point. 0.21. What is the ratio of the Aid flow (current US$) in Kazakhstan in 2000 to that in 2007?
Keep it short and to the point. 1.13. What is the ratio of the Aid flow (current US$) of Tuvalu in 2000 to that in 2007?
Your answer should be very brief. 0.06. What is the ratio of the Aid flow (current US$) in Least developed countries in 2000 to that in 2008?
Your answer should be very brief. 0.16. What is the ratio of the Aid flow (current US$) in Middle East & North Africa (all income levels) in 2000 to that in 2008?
Offer a very short reply. 0.1. What is the ratio of the Aid flow (current US$) in Kazakhstan in 2000 to that in 2008?
Your answer should be very brief. 3.94. What is the ratio of the Aid flow (current US$) in Least developed countries in 2001 to that in 2004?
Offer a very short reply. 0.36. What is the ratio of the Aid flow (current US$) of Middle East & North Africa (all income levels) in 2001 to that in 2004?
Make the answer very short. 0.23. What is the ratio of the Aid flow (current US$) in Kazakhstan in 2001 to that in 2004?
Offer a very short reply. 2.57. What is the ratio of the Aid flow (current US$) of Tuvalu in 2001 to that in 2004?
Offer a terse response. 0.02. What is the ratio of the Aid flow (current US$) of Least developed countries in 2001 to that in 2005?
Your answer should be very brief. 0.28. What is the ratio of the Aid flow (current US$) in Middle East & North Africa (all income levels) in 2001 to that in 2005?
Keep it short and to the point. 0.07. What is the ratio of the Aid flow (current US$) of Kazakhstan in 2001 to that in 2005?
Your answer should be very brief. 1.11. What is the ratio of the Aid flow (current US$) of Tuvalu in 2001 to that in 2005?
Offer a terse response. 0.05. What is the ratio of the Aid flow (current US$) of Least developed countries in 2001 to that in 2007?
Ensure brevity in your answer.  0.17. What is the ratio of the Aid flow (current US$) of Middle East & North Africa (all income levels) in 2001 to that in 2007?
Ensure brevity in your answer.  0.22. What is the ratio of the Aid flow (current US$) of Kazakhstan in 2001 to that in 2007?
Provide a short and direct response. 2.08. What is the ratio of the Aid flow (current US$) of Tuvalu in 2001 to that in 2007?
Your response must be concise. 0.03. What is the ratio of the Aid flow (current US$) in Least developed countries in 2001 to that in 2008?
Offer a terse response. 0.16. What is the ratio of the Aid flow (current US$) of Middle East & North Africa (all income levels) in 2001 to that in 2008?
Your answer should be compact. 0.1. What is the ratio of the Aid flow (current US$) of Kazakhstan in 2001 to that in 2008?
Your answer should be compact. 7.28. What is the ratio of the Aid flow (current US$) in Tuvalu in 2001 to that in 2008?
Provide a succinct answer. 0.5. What is the ratio of the Aid flow (current US$) of Least developed countries in 2004 to that in 2005?
Your response must be concise. 0.77. What is the ratio of the Aid flow (current US$) of Middle East & North Africa (all income levels) in 2004 to that in 2005?
Provide a succinct answer. 0.28. What is the ratio of the Aid flow (current US$) in Kazakhstan in 2004 to that in 2005?
Ensure brevity in your answer.  0.43. What is the ratio of the Aid flow (current US$) in Least developed countries in 2004 to that in 2007?
Your answer should be compact. 0.47. What is the ratio of the Aid flow (current US$) of Middle East & North Africa (all income levels) in 2004 to that in 2007?
Provide a succinct answer. 0.92. What is the ratio of the Aid flow (current US$) in Kazakhstan in 2004 to that in 2007?
Provide a succinct answer. 0.81. What is the ratio of the Aid flow (current US$) in Tuvalu in 2004 to that in 2007?
Ensure brevity in your answer.  1.35. What is the ratio of the Aid flow (current US$) in Least developed countries in 2004 to that in 2008?
Give a very brief answer. 0.45. What is the ratio of the Aid flow (current US$) of Middle East & North Africa (all income levels) in 2004 to that in 2008?
Provide a short and direct response. 0.45. What is the ratio of the Aid flow (current US$) of Kazakhstan in 2004 to that in 2008?
Make the answer very short. 2.83. What is the ratio of the Aid flow (current US$) of Tuvalu in 2004 to that in 2008?
Offer a very short reply. 23. What is the ratio of the Aid flow (current US$) of Least developed countries in 2005 to that in 2007?
Your answer should be very brief. 0.61. What is the ratio of the Aid flow (current US$) in Middle East & North Africa (all income levels) in 2005 to that in 2007?
Your answer should be very brief. 3.26. What is the ratio of the Aid flow (current US$) in Kazakhstan in 2005 to that in 2007?
Provide a short and direct response. 1.87. What is the ratio of the Aid flow (current US$) in Tuvalu in 2005 to that in 2007?
Your response must be concise. 0.59. What is the ratio of the Aid flow (current US$) in Least developed countries in 2005 to that in 2008?
Offer a terse response. 0.59. What is the ratio of the Aid flow (current US$) in Middle East & North Africa (all income levels) in 2005 to that in 2008?
Your answer should be compact. 1.58. What is the ratio of the Aid flow (current US$) in Kazakhstan in 2005 to that in 2008?
Provide a succinct answer. 6.56. What is the ratio of the Aid flow (current US$) of Tuvalu in 2005 to that in 2008?
Your answer should be compact. 10. What is the ratio of the Aid flow (current US$) in Least developed countries in 2007 to that in 2008?
Give a very brief answer. 0.96. What is the ratio of the Aid flow (current US$) in Middle East & North Africa (all income levels) in 2007 to that in 2008?
Provide a succinct answer. 0.49. What is the ratio of the Aid flow (current US$) in Kazakhstan in 2007 to that in 2008?
Make the answer very short. 3.5. What is the difference between the highest and the second highest Aid flow (current US$) in Least developed countries?
Give a very brief answer. 4.93e+07. What is the difference between the highest and the second highest Aid flow (current US$) in Middle East & North Africa (all income levels)?
Your response must be concise. 1.64e+08. What is the difference between the highest and the second highest Aid flow (current US$) in Tuvalu?
Ensure brevity in your answer.  1.20e+05. What is the difference between the highest and the lowest Aid flow (current US$) in Least developed countries?
Provide a succinct answer. 1.02e+09. What is the difference between the highest and the lowest Aid flow (current US$) in Middle East & North Africa (all income levels)?
Offer a terse response. 4.17e+08. What is the difference between the highest and the lowest Aid flow (current US$) in Kazakhstan?
Provide a succinct answer. 1.35e+06. What is the difference between the highest and the lowest Aid flow (current US$) of Tuvalu?
Give a very brief answer. 4.50e+05. 